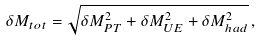Convert formula to latex. <formula><loc_0><loc_0><loc_500><loc_500>\delta M _ { t o t } = \sqrt { \delta M _ { P T } ^ { 2 } + \delta M _ { U E } ^ { 2 } + \delta M _ { h a d } ^ { 2 } } \, ,</formula> 